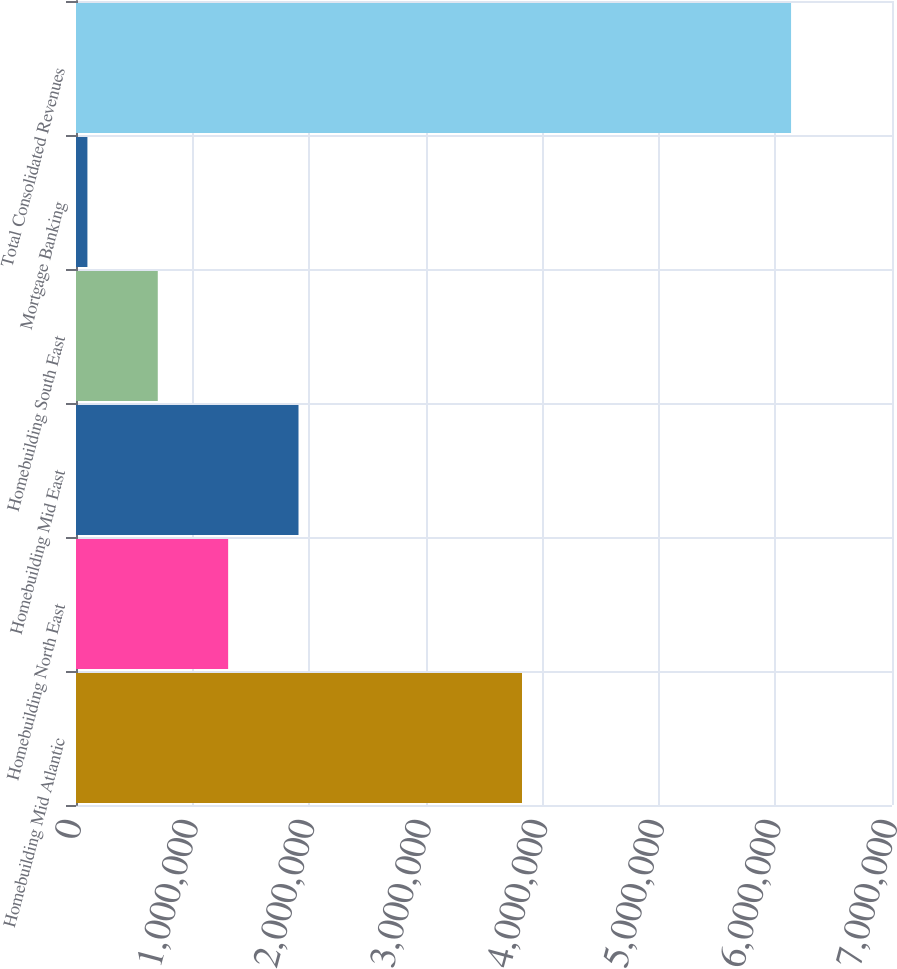Convert chart to OTSL. <chart><loc_0><loc_0><loc_500><loc_500><bar_chart><fcel>Homebuilding Mid Atlantic<fcel>Homebuilding North East<fcel>Homebuilding Mid East<fcel>Homebuilding South East<fcel>Mortgage Banking<fcel>Total Consolidated Revenues<nl><fcel>3.82596e+06<fcel>1.30514e+06<fcel>1.90876e+06<fcel>701512<fcel>97888<fcel>6.13412e+06<nl></chart> 